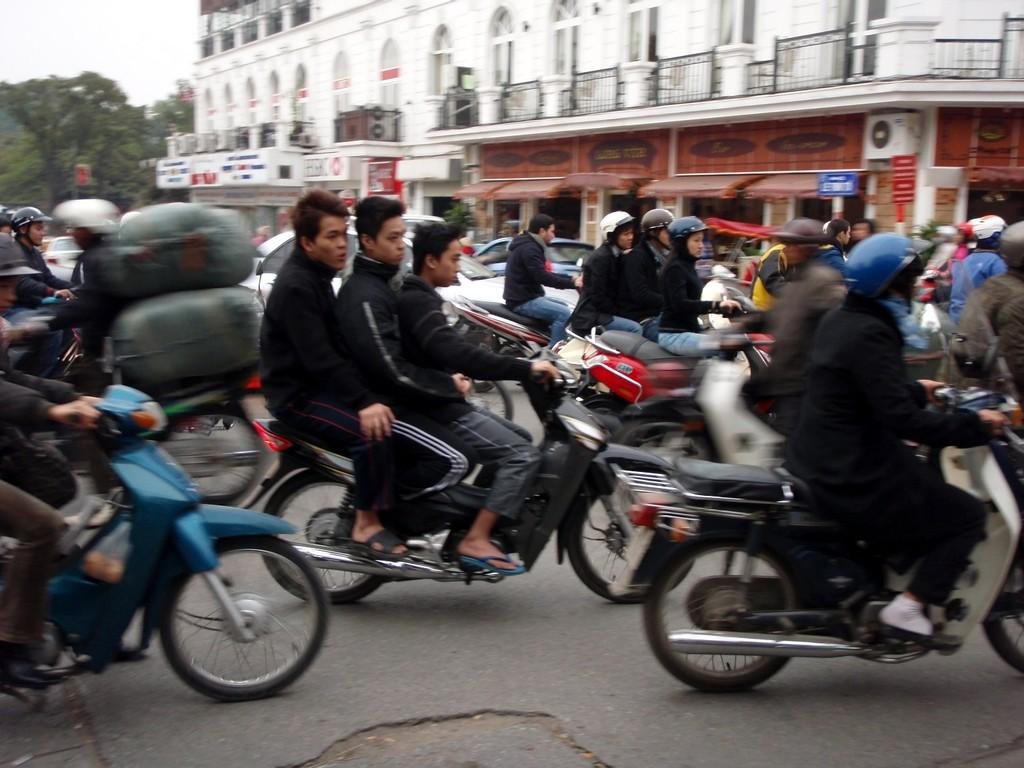Where was the image taken? The image is taken outdoors. What are the people in the image doing? There is a group of people riding bikes in the image. What can be seen in the background of the image? There is a building and trees in the background of the image. What is the color of the building in the background? The building is white in color. What else is visible in the background of the image? The sky is visible in the background of the image. What type of guitar is being played by the person sitting on the throne in the image? There is no person sitting on a throne or playing a guitar in the image; it features a group of people riding bikes outdoors. 